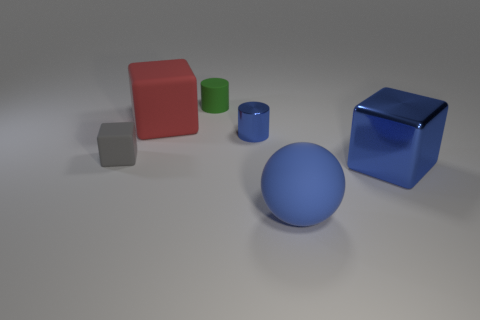Add 2 blue balls. How many objects exist? 8 Subtract all brown cubes. Subtract all yellow spheres. How many cubes are left? 3 Subtract all cylinders. How many objects are left? 4 Subtract all gray things. Subtract all big blue objects. How many objects are left? 3 Add 3 gray cubes. How many gray cubes are left? 4 Add 5 gray matte objects. How many gray matte objects exist? 6 Subtract 1 blue balls. How many objects are left? 5 